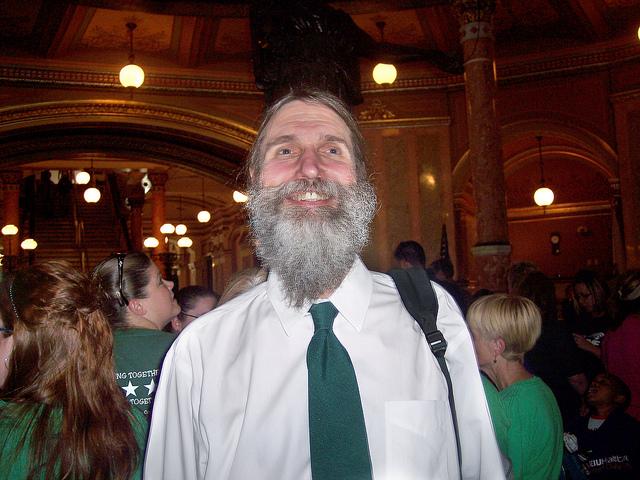What color is the man's tie?
Answer briefly. Green. Does he have a beard?
Write a very short answer. Yes. What does the man have on his shoulder?
Short answer required. Strap. 